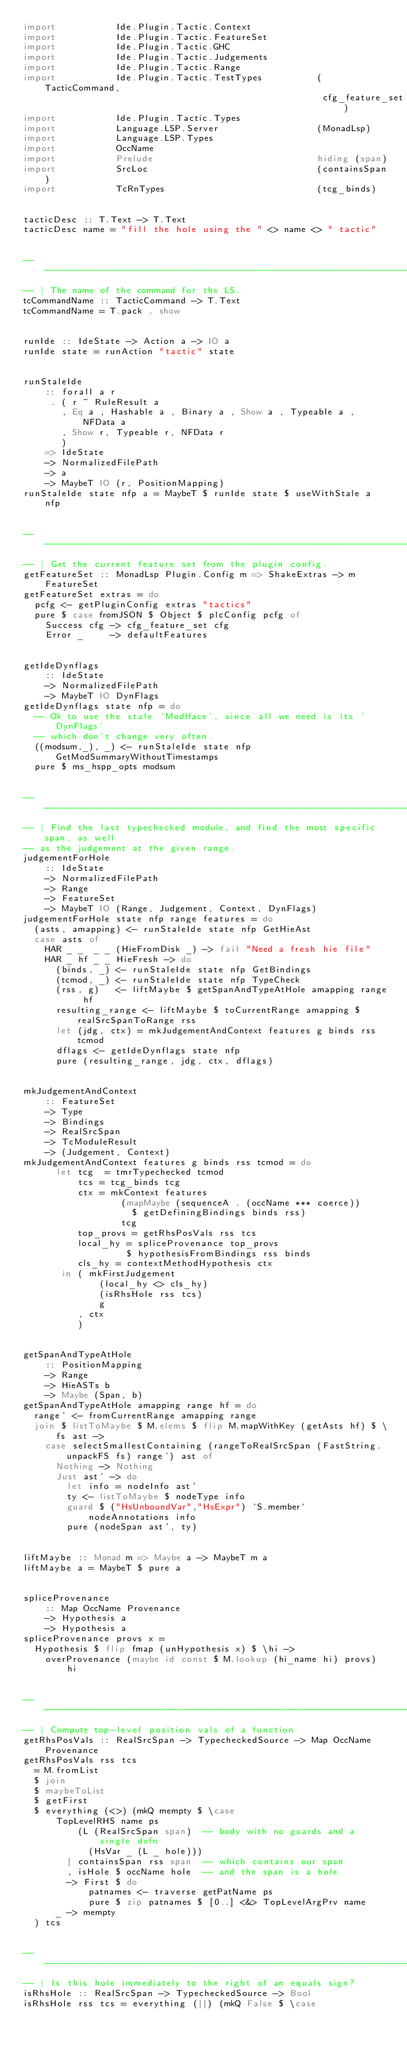Convert code to text. <code><loc_0><loc_0><loc_500><loc_500><_Haskell_>import           Ide.Plugin.Tactic.Context
import           Ide.Plugin.Tactic.FeatureSet
import           Ide.Plugin.Tactic.GHC
import           Ide.Plugin.Tactic.Judgements
import           Ide.Plugin.Tactic.Range
import           Ide.Plugin.Tactic.TestTypes          (TacticCommand,
                                                       cfg_feature_set)
import           Ide.Plugin.Tactic.Types
import           Language.LSP.Server                  (MonadLsp)
import           Language.LSP.Types
import           OccName
import           Prelude                              hiding (span)
import           SrcLoc                               (containsSpan)
import           TcRnTypes                            (tcg_binds)


tacticDesc :: T.Text -> T.Text
tacticDesc name = "fill the hole using the " <> name <> " tactic"


------------------------------------------------------------------------------
-- | The name of the command for the LS.
tcCommandName :: TacticCommand -> T.Text
tcCommandName = T.pack . show


runIde :: IdeState -> Action a -> IO a
runIde state = runAction "tactic" state


runStaleIde
    :: forall a r
     . ( r ~ RuleResult a
       , Eq a , Hashable a , Binary a , Show a , Typeable a , NFData a
       , Show r, Typeable r, NFData r
       )
    => IdeState
    -> NormalizedFilePath
    -> a
    -> MaybeT IO (r, PositionMapping)
runStaleIde state nfp a = MaybeT $ runIde state $ useWithStale a nfp


------------------------------------------------------------------------------
-- | Get the current feature set from the plugin config.
getFeatureSet :: MonadLsp Plugin.Config m => ShakeExtras -> m FeatureSet
getFeatureSet extras = do
  pcfg <- getPluginConfig extras "tactics"
  pure $ case fromJSON $ Object $ plcConfig pcfg of
    Success cfg -> cfg_feature_set cfg
    Error _     -> defaultFeatures


getIdeDynflags
    :: IdeState
    -> NormalizedFilePath
    -> MaybeT IO DynFlags
getIdeDynflags state nfp = do
  -- Ok to use the stale 'ModIface', since all we need is its 'DynFlags'
  -- which don't change very often.
  ((modsum,_), _) <- runStaleIde state nfp GetModSummaryWithoutTimestamps
  pure $ ms_hspp_opts modsum


------------------------------------------------------------------------------
-- | Find the last typechecked module, and find the most specific span, as well
-- as the judgement at the given range.
judgementForHole
    :: IdeState
    -> NormalizedFilePath
    -> Range
    -> FeatureSet
    -> MaybeT IO (Range, Judgement, Context, DynFlags)
judgementForHole state nfp range features = do
  (asts, amapping) <- runStaleIde state nfp GetHieAst
  case asts of
    HAR _ _  _ _ (HieFromDisk _) -> fail "Need a fresh hie file"
    HAR _ hf _ _ HieFresh -> do
      (binds, _) <- runStaleIde state nfp GetBindings
      (tcmod, _) <- runStaleIde state nfp TypeCheck
      (rss, g)   <- liftMaybe $ getSpanAndTypeAtHole amapping range hf
      resulting_range <- liftMaybe $ toCurrentRange amapping $ realSrcSpanToRange rss
      let (jdg, ctx) = mkJudgementAndContext features g binds rss tcmod
      dflags <- getIdeDynflags state nfp
      pure (resulting_range, jdg, ctx, dflags)


mkJudgementAndContext
    :: FeatureSet
    -> Type
    -> Bindings
    -> RealSrcSpan
    -> TcModuleResult
    -> (Judgement, Context)
mkJudgementAndContext features g binds rss tcmod = do
      let tcg  = tmrTypechecked tcmod
          tcs = tcg_binds tcg
          ctx = mkContext features
                  (mapMaybe (sequenceA . (occName *** coerce))
                    $ getDefiningBindings binds rss)
                  tcg
          top_provs = getRhsPosVals rss tcs
          local_hy = spliceProvenance top_provs
                   $ hypothesisFromBindings rss binds
          cls_hy = contextMethodHypothesis ctx
       in ( mkFirstJudgement
              (local_hy <> cls_hy)
              (isRhsHole rss tcs)
              g
          , ctx
          )


getSpanAndTypeAtHole
    :: PositionMapping
    -> Range
    -> HieASTs b
    -> Maybe (Span, b)
getSpanAndTypeAtHole amapping range hf = do
  range' <- fromCurrentRange amapping range
  join $ listToMaybe $ M.elems $ flip M.mapWithKey (getAsts hf) $ \fs ast ->
    case selectSmallestContaining (rangeToRealSrcSpan (FastString.unpackFS fs) range') ast of
      Nothing -> Nothing
      Just ast' -> do
        let info = nodeInfo ast'
        ty <- listToMaybe $ nodeType info
        guard $ ("HsUnboundVar","HsExpr") `S.member` nodeAnnotations info
        pure (nodeSpan ast', ty)


liftMaybe :: Monad m => Maybe a -> MaybeT m a
liftMaybe a = MaybeT $ pure a


spliceProvenance
    :: Map OccName Provenance
    -> Hypothesis a
    -> Hypothesis a
spliceProvenance provs x =
  Hypothesis $ flip fmap (unHypothesis x) $ \hi ->
    overProvenance (maybe id const $ M.lookup (hi_name hi) provs) hi


------------------------------------------------------------------------------
-- | Compute top-level position vals of a function
getRhsPosVals :: RealSrcSpan -> TypecheckedSource -> Map OccName Provenance
getRhsPosVals rss tcs
  = M.fromList
  $ join
  $ maybeToList
  $ getFirst
  $ everything (<>) (mkQ mempty $ \case
      TopLevelRHS name ps
          (L (RealSrcSpan span)  -- body with no guards and a single defn
            (HsVar _ (L _ hole)))
        | containsSpan rss span  -- which contains our span
        , isHole $ occName hole  -- and the span is a hole
        -> First $ do
            patnames <- traverse getPatName ps
            pure $ zip patnames $ [0..] <&> TopLevelArgPrv name
      _ -> mempty
  ) tcs


------------------------------------------------------------------------------
-- | Is this hole immediately to the right of an equals sign?
isRhsHole :: RealSrcSpan -> TypecheckedSource -> Bool
isRhsHole rss tcs = everything (||) (mkQ False $ \case</code> 